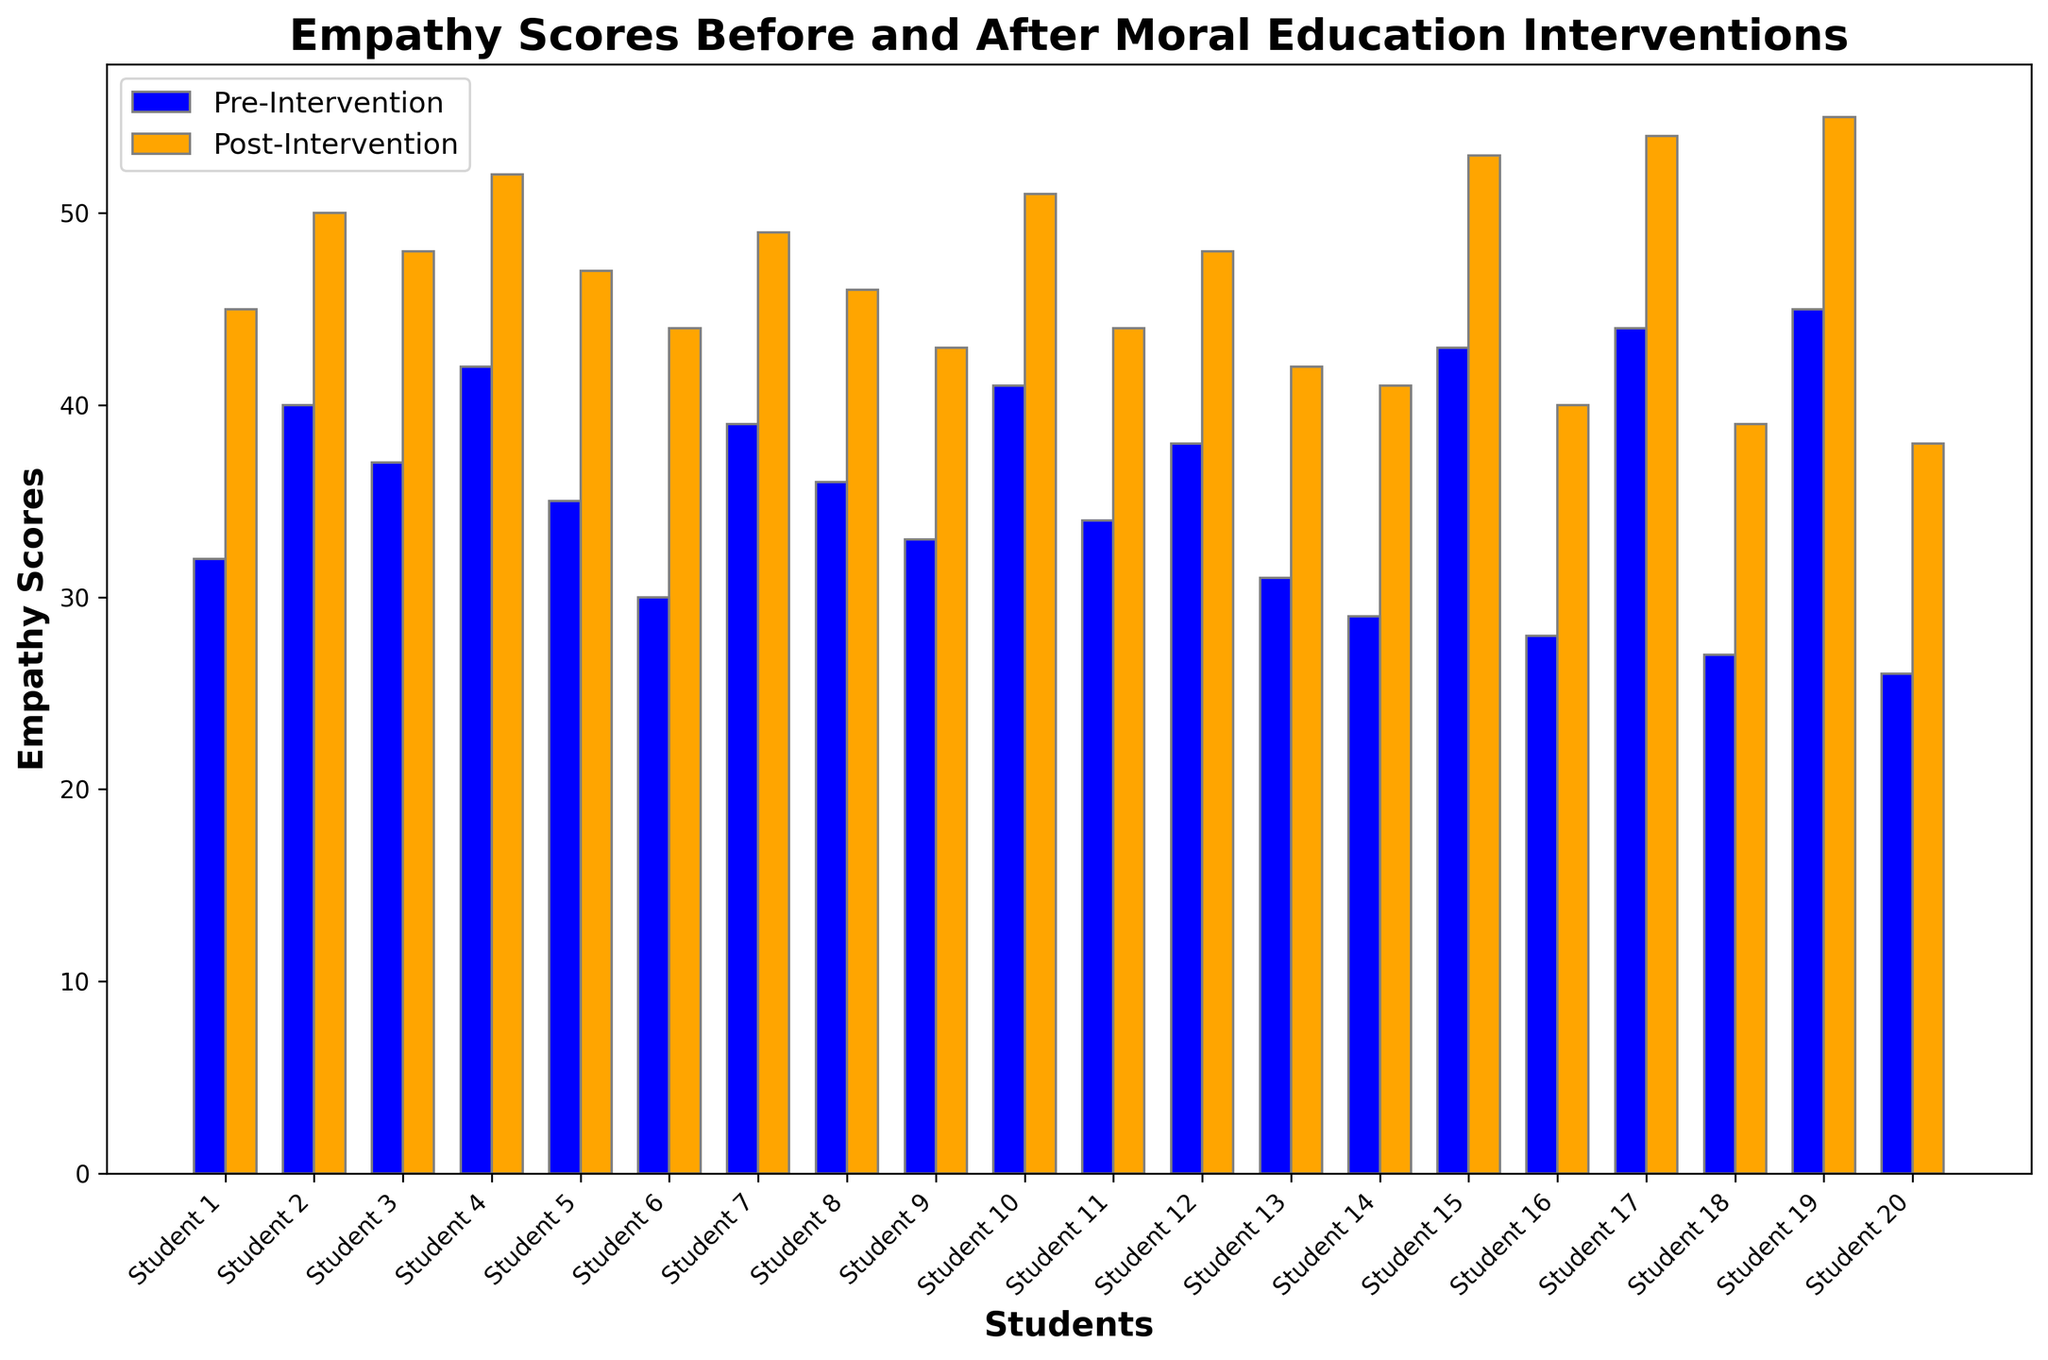What's the overall trend observed in empathy scores after the intervention? Looking at the heights of the bars, the post-intervention empathy scores (orange bars) are higher than the pre-intervention scores (blue bars) for all students, indicating an overall increase in empathy levels.
Answer: Increase Which student showed the greatest increase in empathy scores after the intervention? To identify the student with the greatest increase, we calculate the difference between the post-intervention and pre-intervention scores for all students. Student 19 has the highest increase (55 - 45 = 10).
Answer: Student 19 Is there any student whose empathy score did not increase post-intervention? By comparing the blue and orange bars for each student, all orange bars are higher than the blue bars. Therefore, every student's empathy score increased post-intervention.
Answer: No What is the average increase in empathy scores post-intervention? Calculate the difference between post-intervention and pre-intervention scores for all students and find the average: (45-32 + 50-40 + 48-37 + 52-42 + 47-35 + 44-30 + 49-39 + 46-36 + 43-33 + 51-41 + 44-34 + 48-38 + 42-31 + 41-29 + 53-43 + 40-28 + 54-44 + 39-27 + 55-45 + 38-26) / 20 = 10.1
Answer: 10.1 Which student had a post-intervention score closest to 50? By examining the post-intervention scores, Student 2 has a post-intervention score of 50, which is the closest to 50.
Answer: Student 2 How many students had a pre-intervention empathy score above 40? Count the number of blue bars above the score of 40, which are students 4, 10, 15, 17, and 19. There are 5 such students.
Answer: 5 What is the difference in empathy scores for Student 1 before and after the intervention? Calculate the difference for Student 1: 45 - 32 = 13.
Answer: 13 How do the empathy scores compare between Student 17 and Student 18 after the intervention? Compare the post-intervention scores for both students. Student 17 has a score of 54, and Student 18 has a score of 39, so Student 17's score is higher.
Answer: Student 17's score is higher Which student had the lowest pre-intervention empathy score and how did their score change? The lowest pre-intervention score is 26 for Student 20. Calculate the change: 38 - 26 = 12.
Answer: Student 20, change of 12 What was the average post-intervention empathy score? Add all post-intervention scores and divide by the number of students: (45 + 50 + 48 + 52 + 47 + 44 + 49 + 46 + 43 + 51 + 44 + 48 + 42 + 41 + 53 + 40 + 54 + 39 + 55 + 38) / 20 = 46.3.
Answer: 46.3 